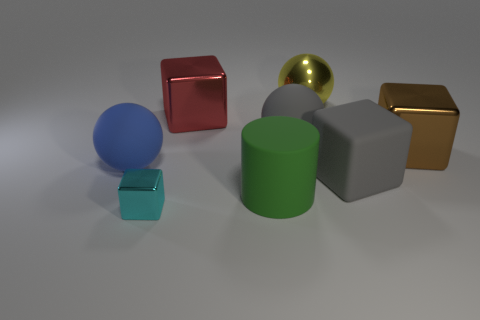Which objects in the image are closest to each other? The closest objects are the small teal cube and the big blue sphere; they appear to be positioned right next to each other. 